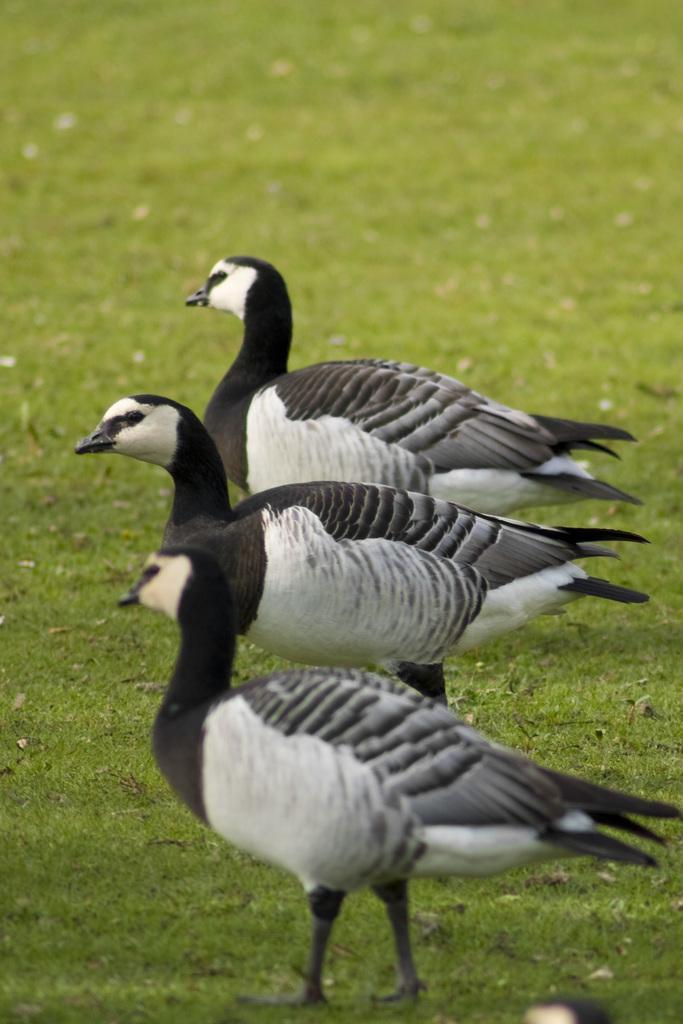How would you summarize this image in a sentence or two? in the image there are three birds standing on the grassland. 